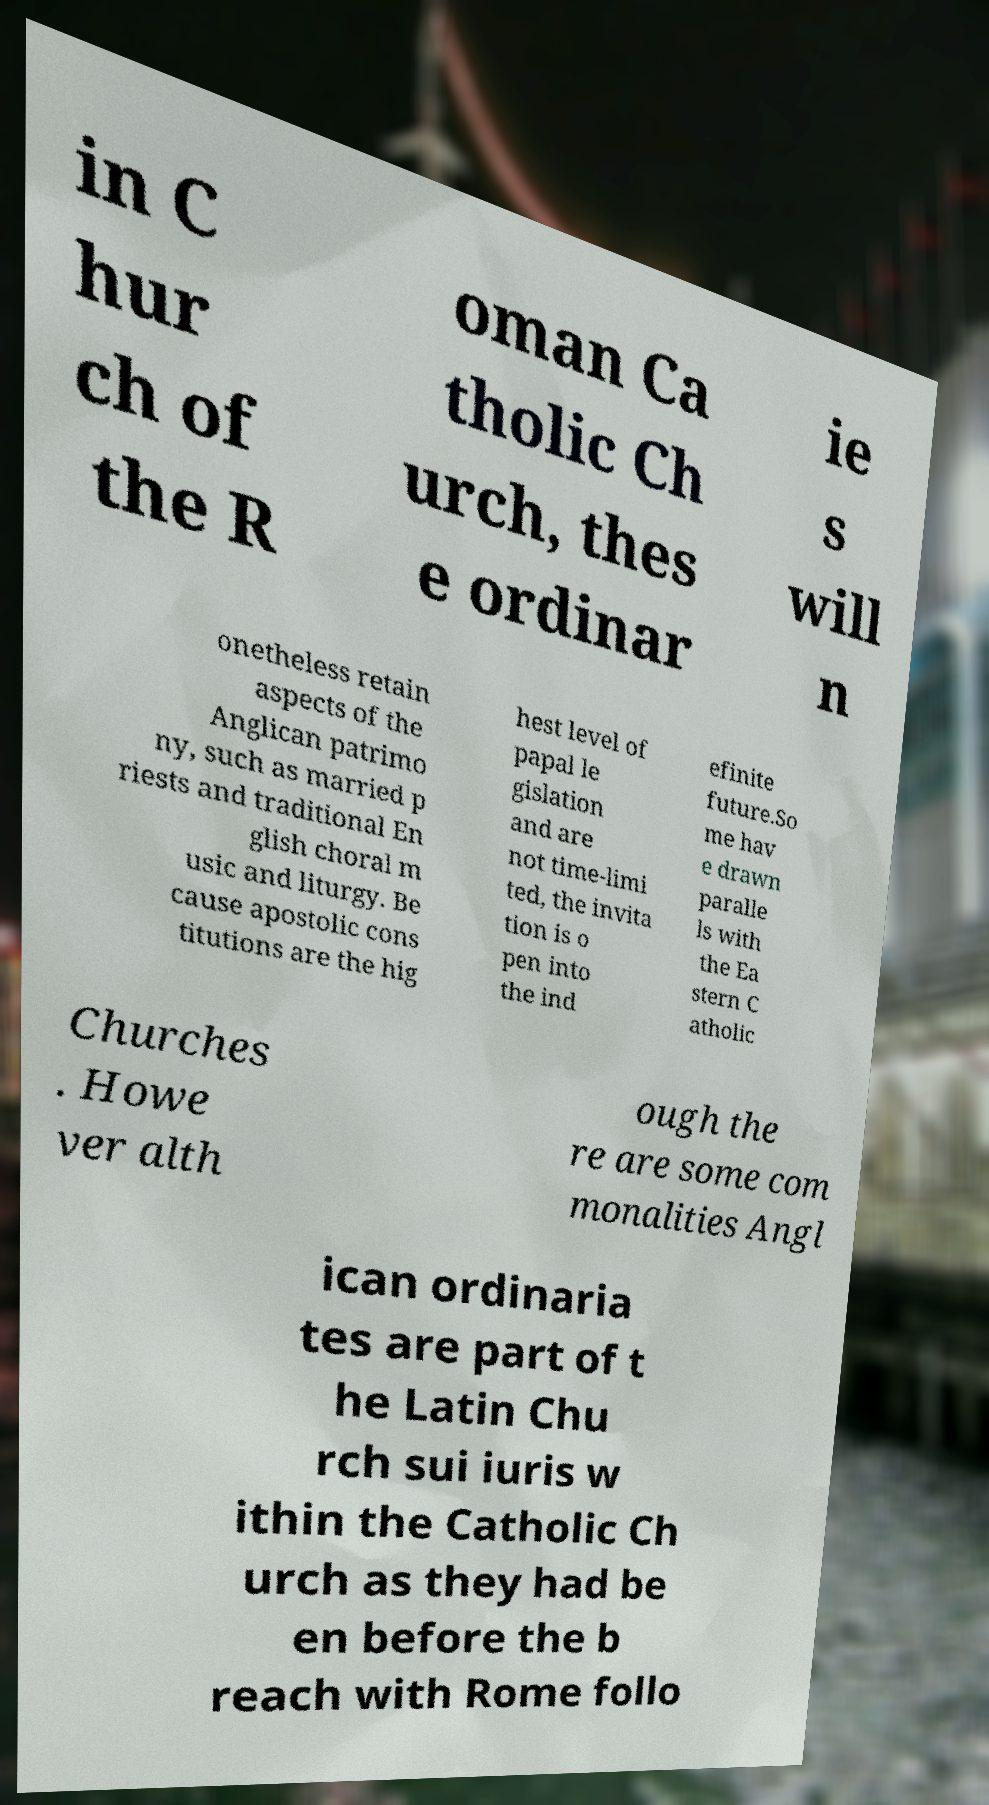I need the written content from this picture converted into text. Can you do that? in C hur ch of the R oman Ca tholic Ch urch, thes e ordinar ie s will n onetheless retain aspects of the Anglican patrimo ny, such as married p riests and traditional En glish choral m usic and liturgy. Be cause apostolic cons titutions are the hig hest level of papal le gislation and are not time-limi ted, the invita tion is o pen into the ind efinite future.So me hav e drawn paralle ls with the Ea stern C atholic Churches . Howe ver alth ough the re are some com monalities Angl ican ordinaria tes are part of t he Latin Chu rch sui iuris w ithin the Catholic Ch urch as they had be en before the b reach with Rome follo 